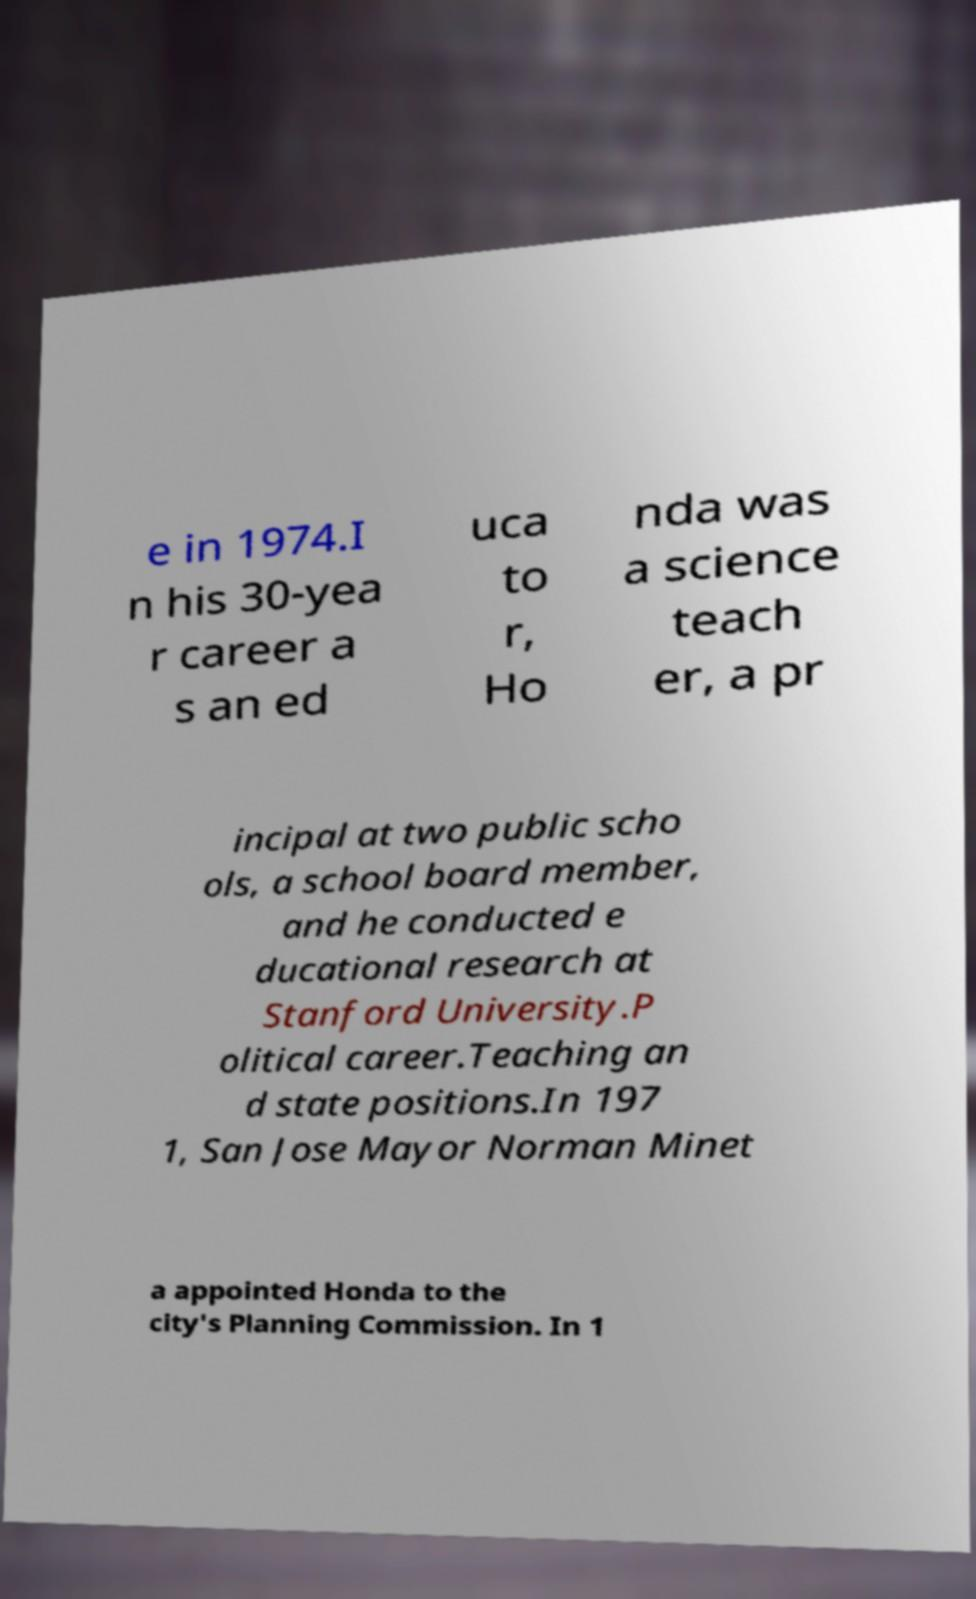Could you assist in decoding the text presented in this image and type it out clearly? e in 1974.I n his 30-yea r career a s an ed uca to r, Ho nda was a science teach er, a pr incipal at two public scho ols, a school board member, and he conducted e ducational research at Stanford University.P olitical career.Teaching an d state positions.In 197 1, San Jose Mayor Norman Minet a appointed Honda to the city's Planning Commission. In 1 